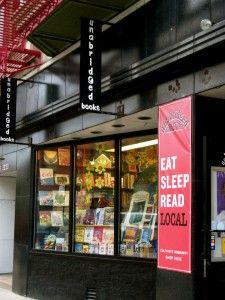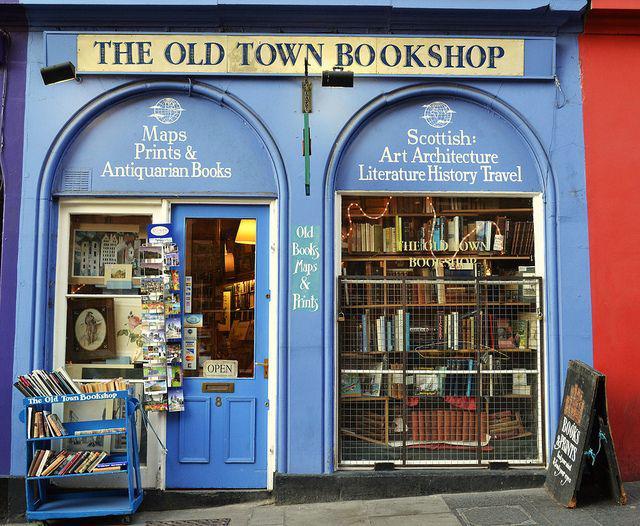The first image is the image on the left, the second image is the image on the right. Evaluate the accuracy of this statement regarding the images: "In the image to the right, the outside of the old bookshop has some blue paint.". Is it true? Answer yes or no. Yes. The first image is the image on the left, the second image is the image on the right. For the images displayed, is the sentence "The door in the image on the right is open." factually correct? Answer yes or no. No. 